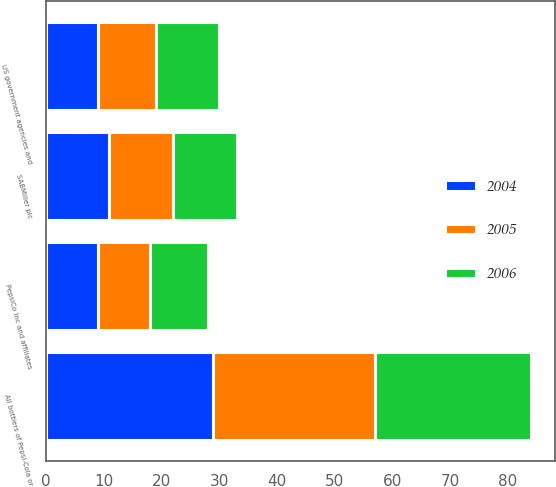Convert chart. <chart><loc_0><loc_0><loc_500><loc_500><stacked_bar_chart><ecel><fcel>SABMiller plc<fcel>PepsiCo Inc and affiliates<fcel>All bottlers of Pepsi-Cola or<fcel>US government agencies and<nl><fcel>2004<fcel>11<fcel>9<fcel>29<fcel>9<nl><fcel>2006<fcel>11<fcel>10<fcel>27<fcel>11<nl><fcel>2005<fcel>11<fcel>9<fcel>28<fcel>10<nl></chart> 